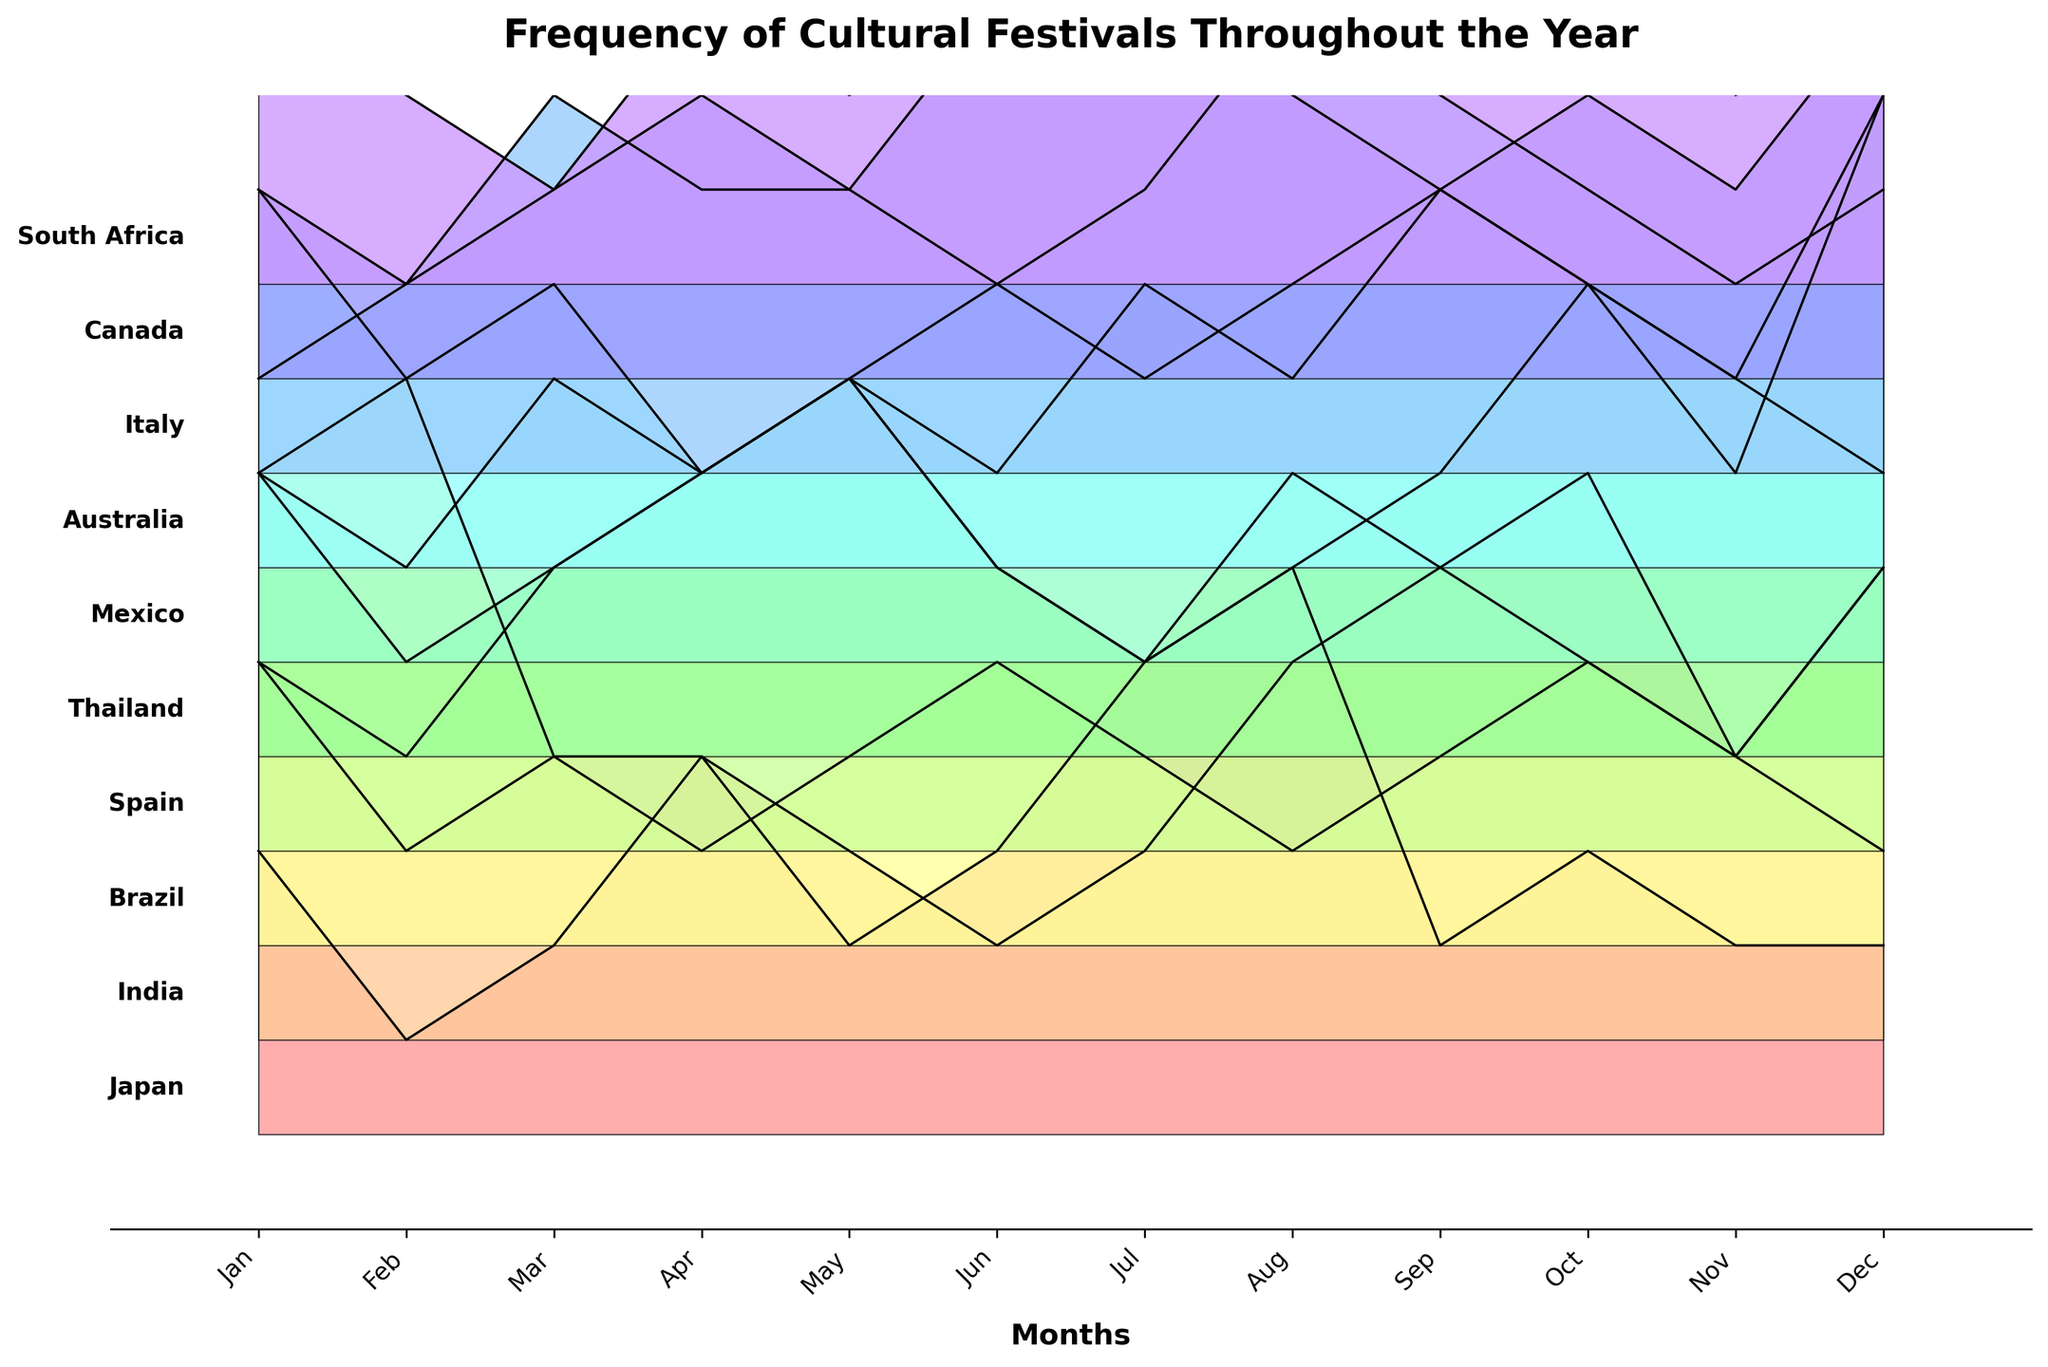What is the title of the plot? The title is usually located at the top of the plot. The title here is "Frequency of Cultural Festivals Throughout the Year".
Answer: Frequency of Cultural Festivals Throughout the Year Which country has the highest frequency of cultural festivals in January? Find January on the x-axis and look for the tallest peak across all countries. Brazil's peak in January is the highest.
Answer: Brazil In which month does Spain have the highest frequency of cultural festivals? Locate the distribution for Spain and identify the month where this country has the largest peak. Spain's highest peak is in May.
Answer: May How many countries have a visible peak in August? Follow the line for August on the x-axis and count the countries that have a noticeable peak. Japan, India, Thailand, Italy, Canada, and Australia all show peaks in August.
Answer: 6 Which country shows the least variation in the frequency of festivals throughout the year? Look for a country where the distribution is relatively flat or has the smallest peaks and valleys. Canada has a relatively flat distribution when compared to others.
Answer: Canada Which months have the highest number of festivals in Mexico? Identify the x-axis positions with the highest peaks for Mexico. The months with the most noticeable peaks for Mexico are December and September.
Answer: December and September What is the average number of festivals in May across all countries? Find the values for May for each country and calculate the average. The values are 2, 2, 2, 5, 4, 3, 2, 3, 2, and 2. The sum is 27, and there are 10 countries, so the average is 27/10.
Answer: 2.7 In which month is the frequency of festivals equal for both Japan and Thailand? Compare the distributions of Japan and Thailand and find any month where their peaks match. In January, both Japan and Thailand have a frequency of 3.
Answer: January Which country has the most significant peak difference between December and June? Compare the height of peaks in December and June for each country and find the maximum difference. Mexico shows a peak of 6 in December and 2 in June, a difference of 4.
Answer: Mexico 